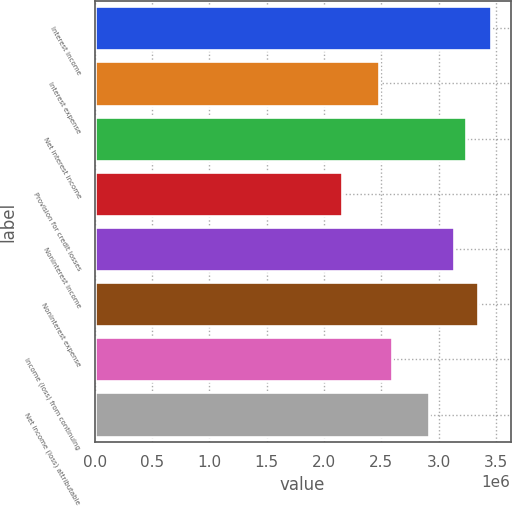<chart> <loc_0><loc_0><loc_500><loc_500><bar_chart><fcel>Interest income<fcel>Interest expense<fcel>Net interest income<fcel>Provision for credit losses<fcel>Noninterest income<fcel>Noninterest expense<fcel>Income (loss) from continuing<fcel>Net income (loss) attributable<nl><fcel>3.45386e+06<fcel>2.48246e+06<fcel>3.23799e+06<fcel>2.15866e+06<fcel>3.13006e+06<fcel>3.34592e+06<fcel>2.59039e+06<fcel>2.91419e+06<nl></chart> 